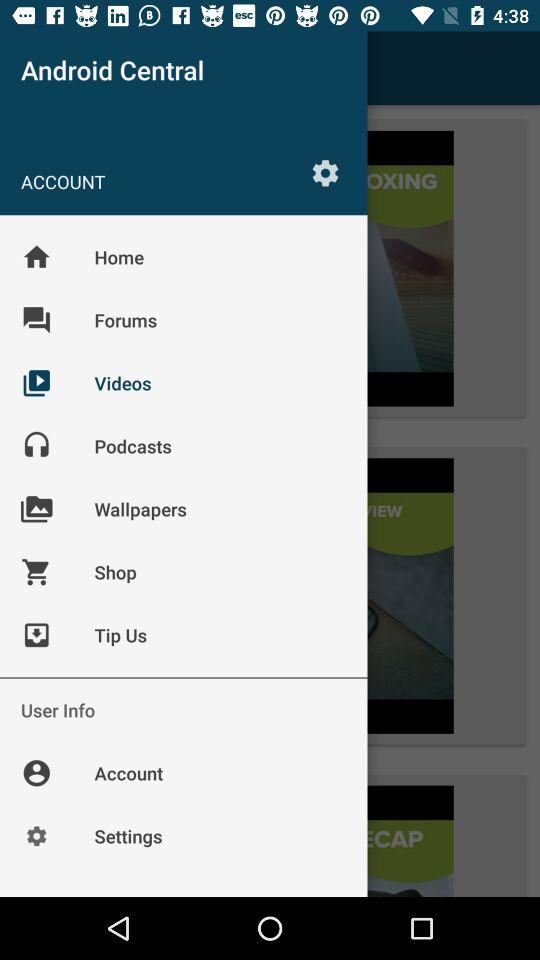Which option is currently selected? The currently selected option is "Videos". 